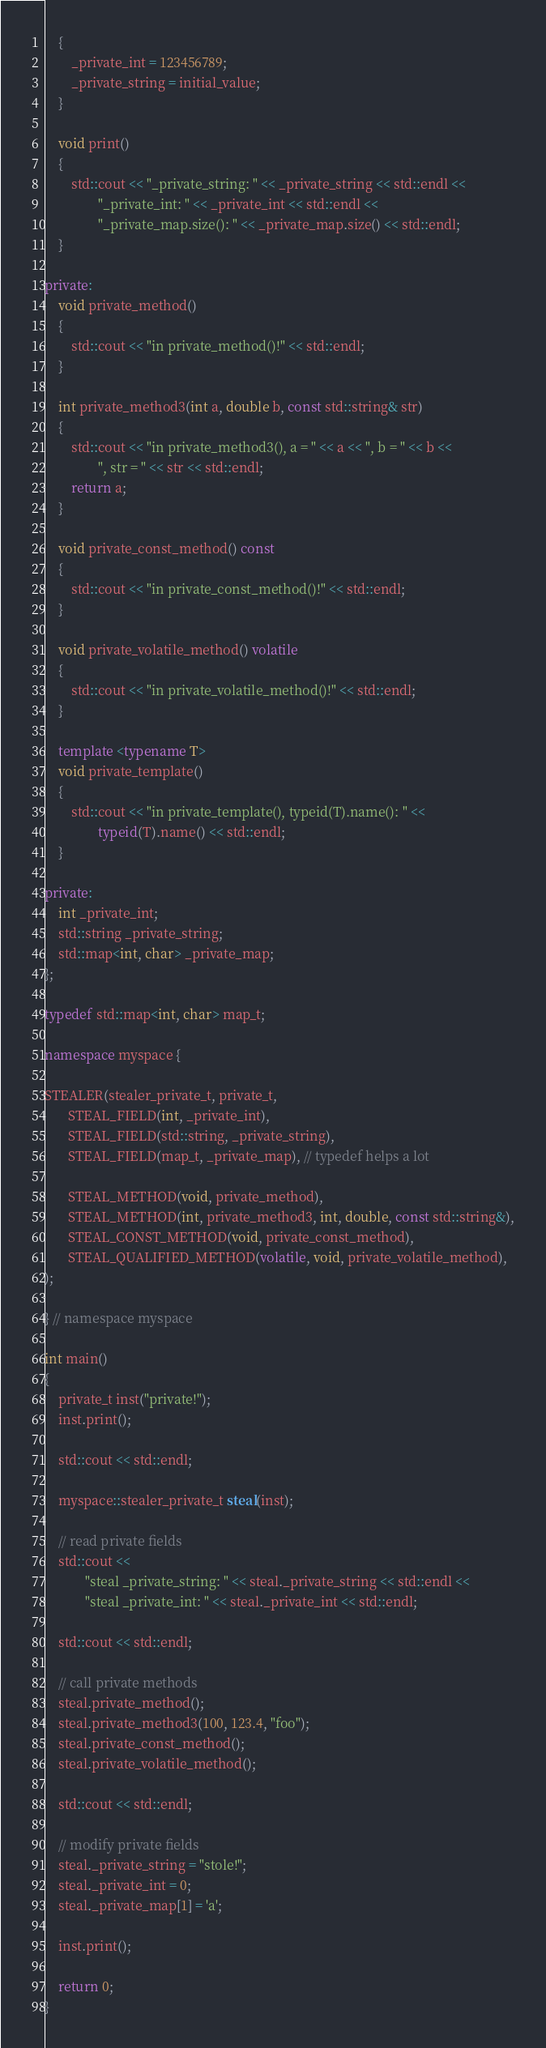<code> <loc_0><loc_0><loc_500><loc_500><_C++_>    {
        _private_int = 123456789;
        _private_string = initial_value;
    }

    void print()
    {
        std::cout << "_private_string: " << _private_string << std::endl <<
                "_private_int: " << _private_int << std::endl <<
                "_private_map.size(): " << _private_map.size() << std::endl;
    }

private:
    void private_method()
    {
        std::cout << "in private_method()!" << std::endl;
    }

    int private_method3(int a, double b, const std::string& str)
    {
        std::cout << "in private_method3(), a = " << a << ", b = " << b <<
                ", str = " << str << std::endl;
        return a;
    }

    void private_const_method() const
    {
        std::cout << "in private_const_method()!" << std::endl;
    }

    void private_volatile_method() volatile
    {
        std::cout << "in private_volatile_method()!" << std::endl;
    }

    template <typename T>
    void private_template()
    {
        std::cout << "in private_template(), typeid(T).name(): " <<
                typeid(T).name() << std::endl;
    }

private:
    int _private_int;
    std::string _private_string;
    std::map<int, char> _private_map;
};

typedef std::map<int, char> map_t;

namespace myspace {

STEALER(stealer_private_t, private_t,
       STEAL_FIELD(int, _private_int),
       STEAL_FIELD(std::string, _private_string),
       STEAL_FIELD(map_t, _private_map), // typedef helps a lot

       STEAL_METHOD(void, private_method),
       STEAL_METHOD(int, private_method3, int, double, const std::string&),
       STEAL_CONST_METHOD(void, private_const_method),
       STEAL_QUALIFIED_METHOD(volatile, void, private_volatile_method),
);

} // namespace myspace

int main()
{
    private_t inst("private!");
    inst.print();

    std::cout << std::endl;

    myspace::stealer_private_t steal(inst);

    // read private fields
    std::cout <<
            "steal _private_string: " << steal._private_string << std::endl <<
            "steal _private_int: " << steal._private_int << std::endl;

    std::cout << std::endl;

    // call private methods
    steal.private_method();
    steal.private_method3(100, 123.4, "foo");
    steal.private_const_method();
    steal.private_volatile_method();

    std::cout << std::endl;

    // modify private fields
    steal._private_string = "stole!";
    steal._private_int = 0;
    steal._private_map[1] = 'a';

    inst.print();

    return 0;
}
</code> 